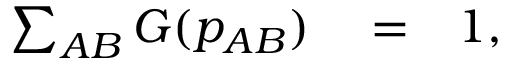Convert formula to latex. <formula><loc_0><loc_0><loc_500><loc_500>\begin{array} { r l r } { \sum _ { A B } G ( p _ { A B } ) } & = } & { 1 , } \end{array}</formula> 